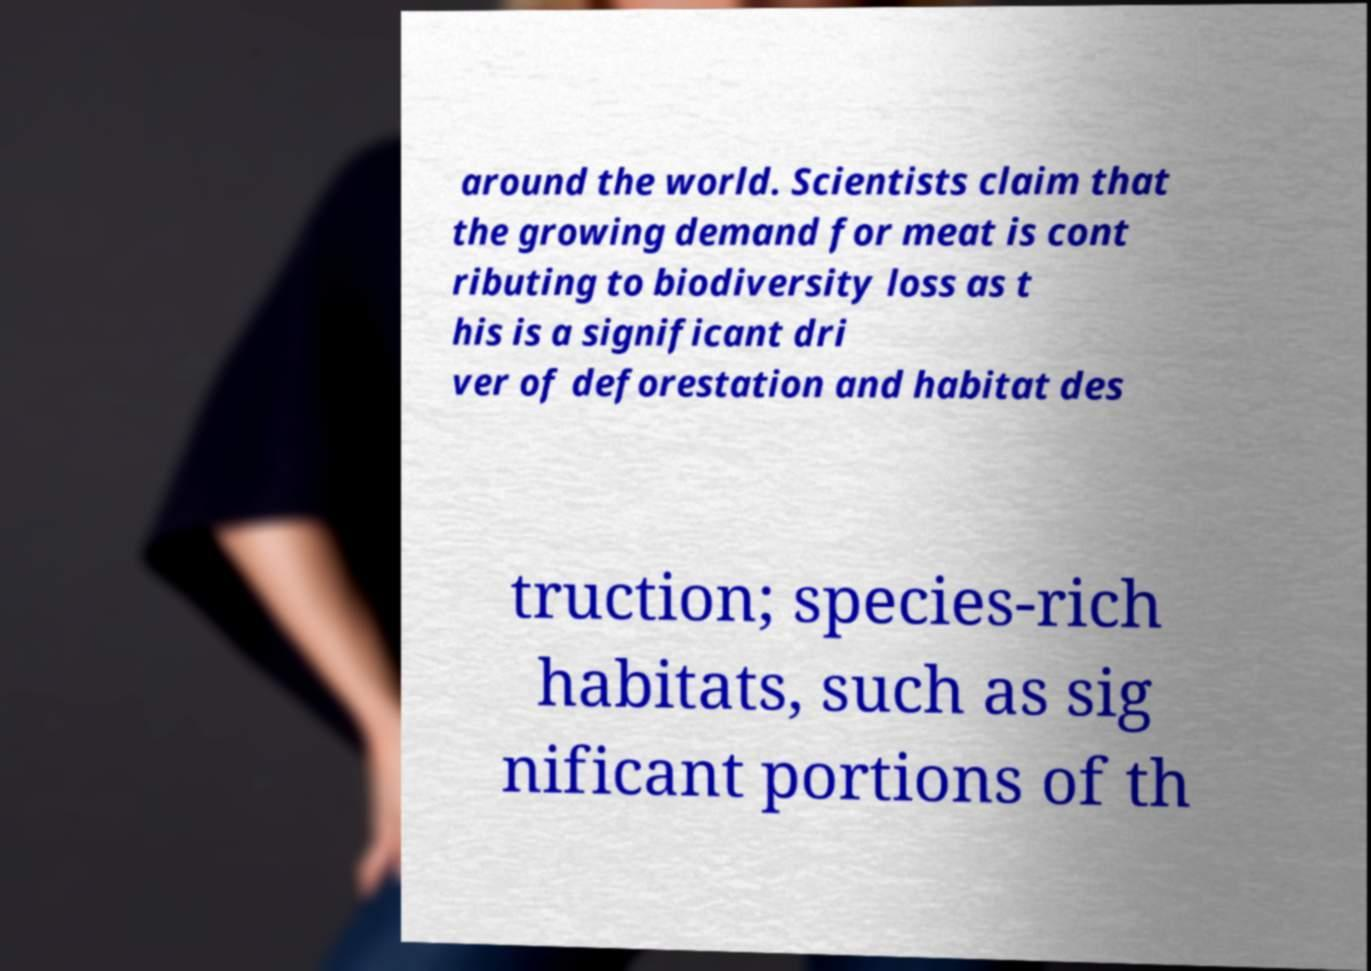For documentation purposes, I need the text within this image transcribed. Could you provide that? around the world. Scientists claim that the growing demand for meat is cont ributing to biodiversity loss as t his is a significant dri ver of deforestation and habitat des truction; species-rich habitats, such as sig nificant portions of th 